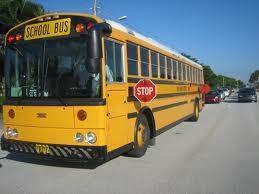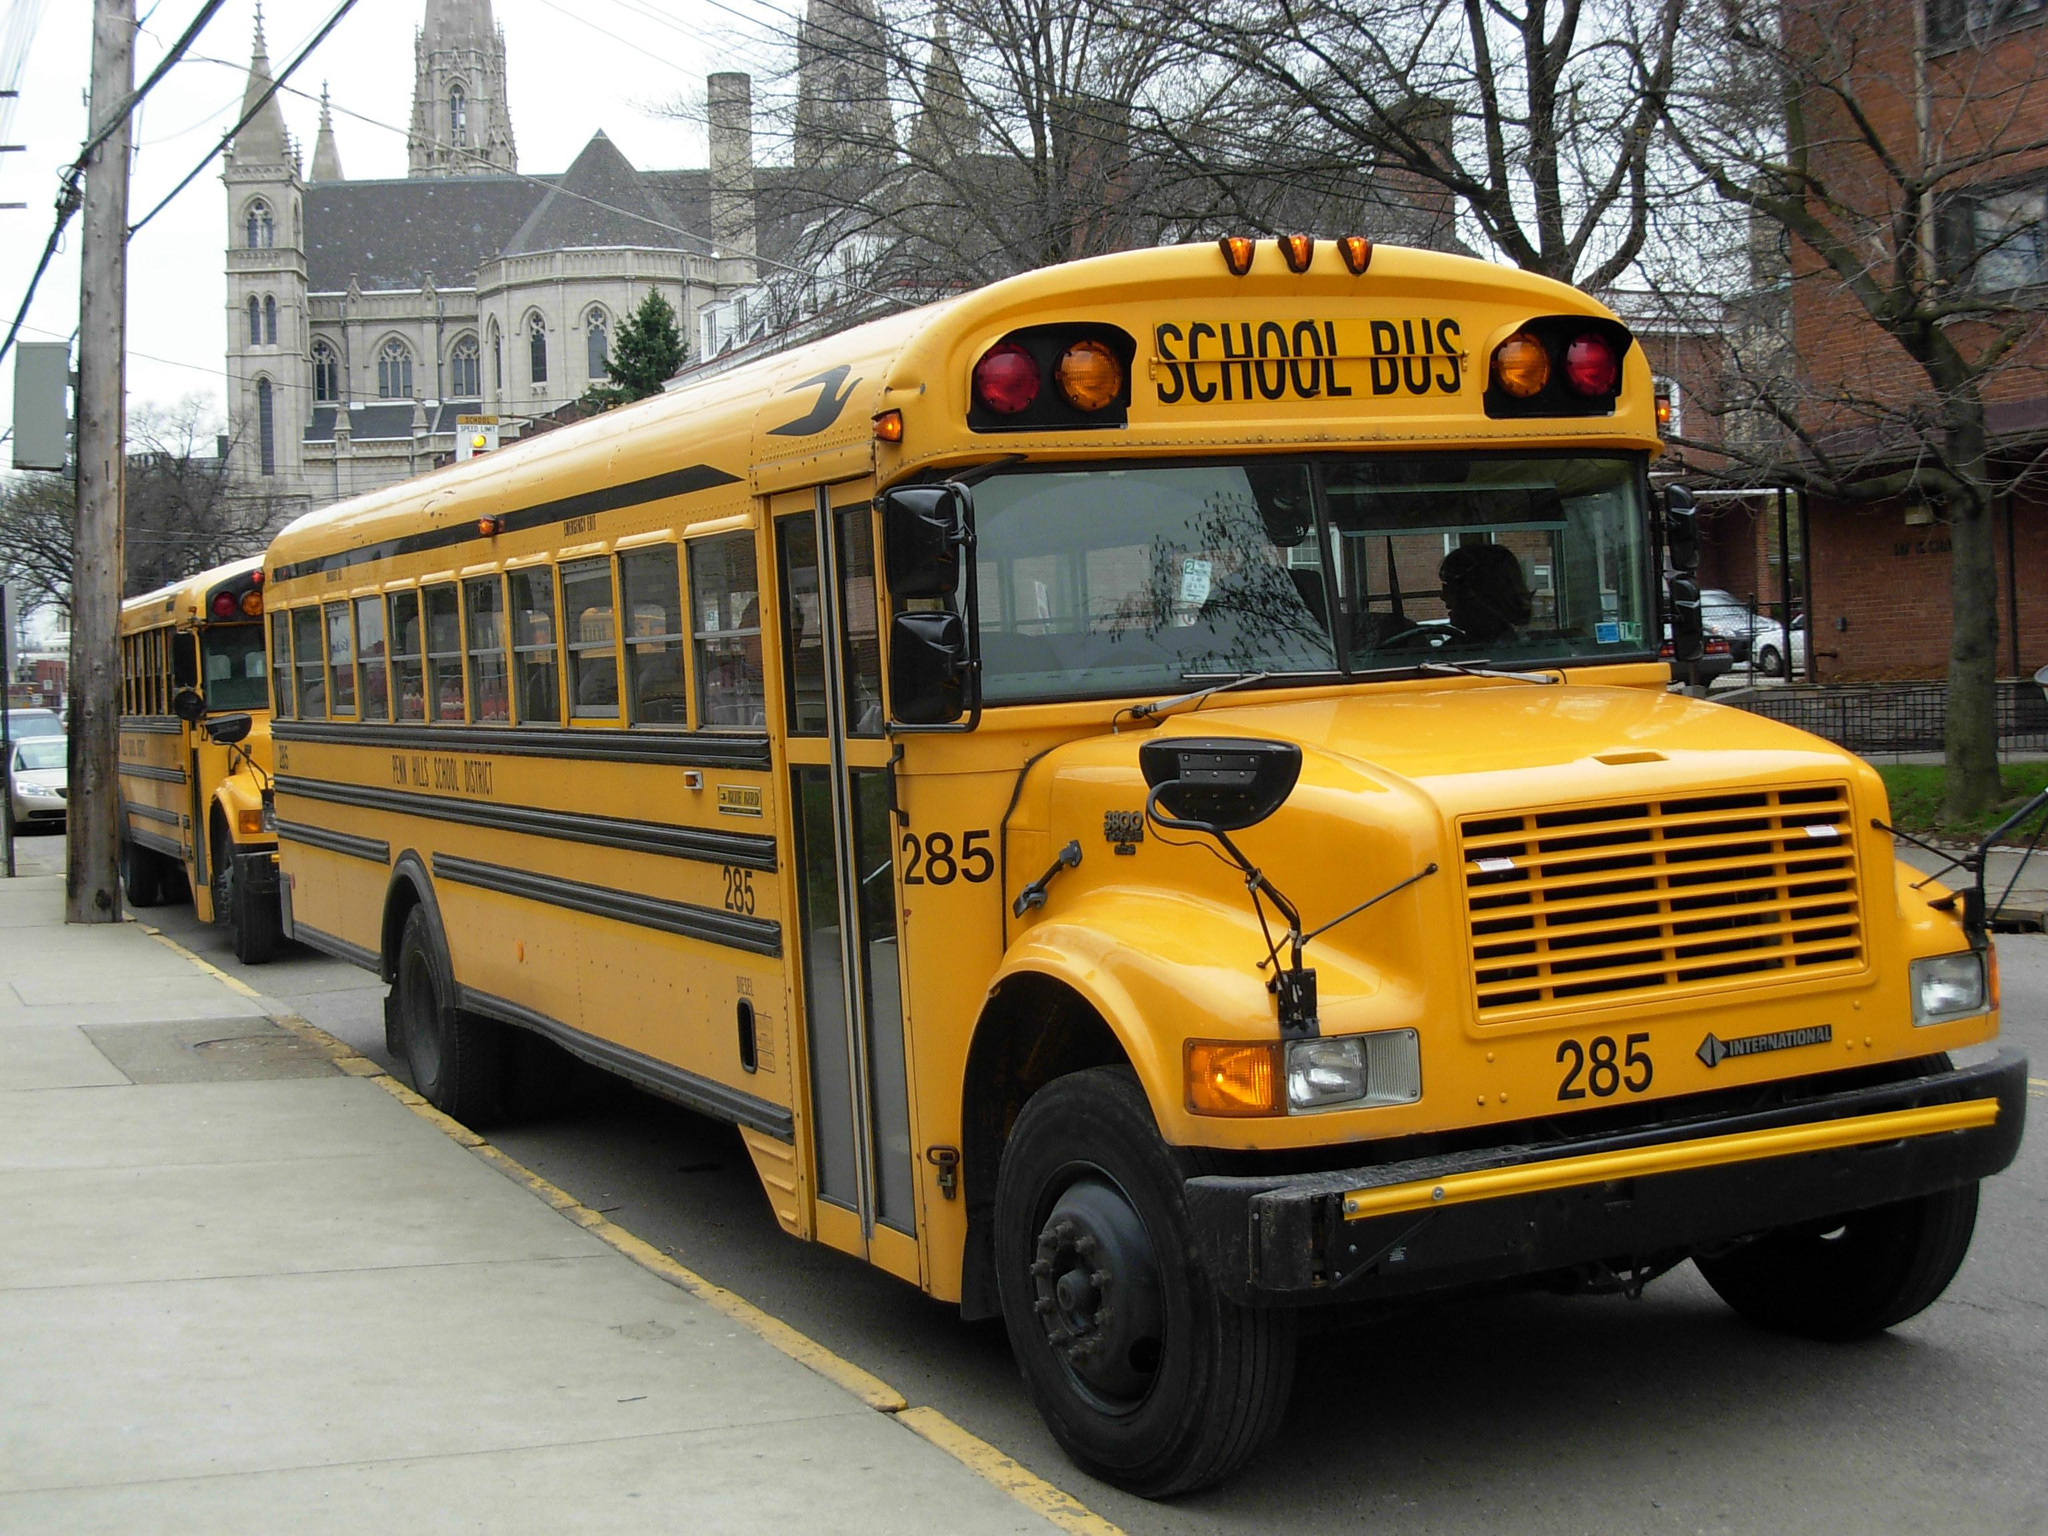The first image is the image on the left, the second image is the image on the right. For the images displayed, is the sentence "The left side of a bus is visible." factually correct? Answer yes or no. Yes. The first image is the image on the left, the second image is the image on the right. For the images displayed, is the sentence "Each image features an angled forward-facing bus, but the buses in the left and right images face opposite directions." factually correct? Answer yes or no. Yes. 